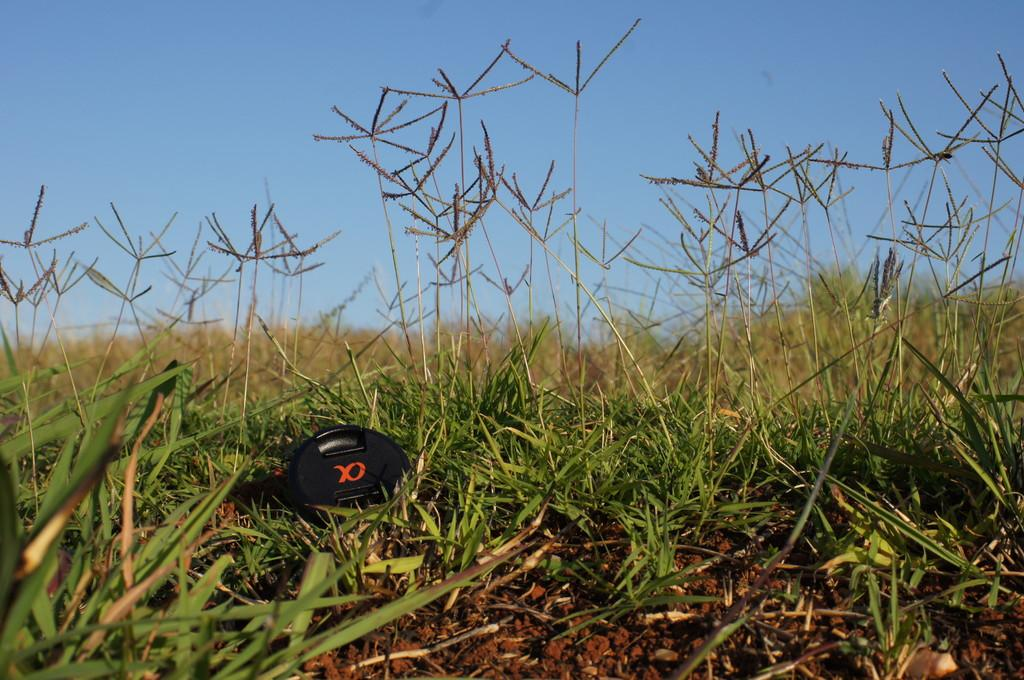What is the main subject of the image? There is a black object in the image. Where is the black object located? The black object is on a grassy land. What can be seen in the background of the image? The sky is visible in the background of the image. What type of manager is overseeing the basketball scene in the image? There is no manager or basketball scene present in the image; it only features a black object on a grassy land with the sky visible in the background. 